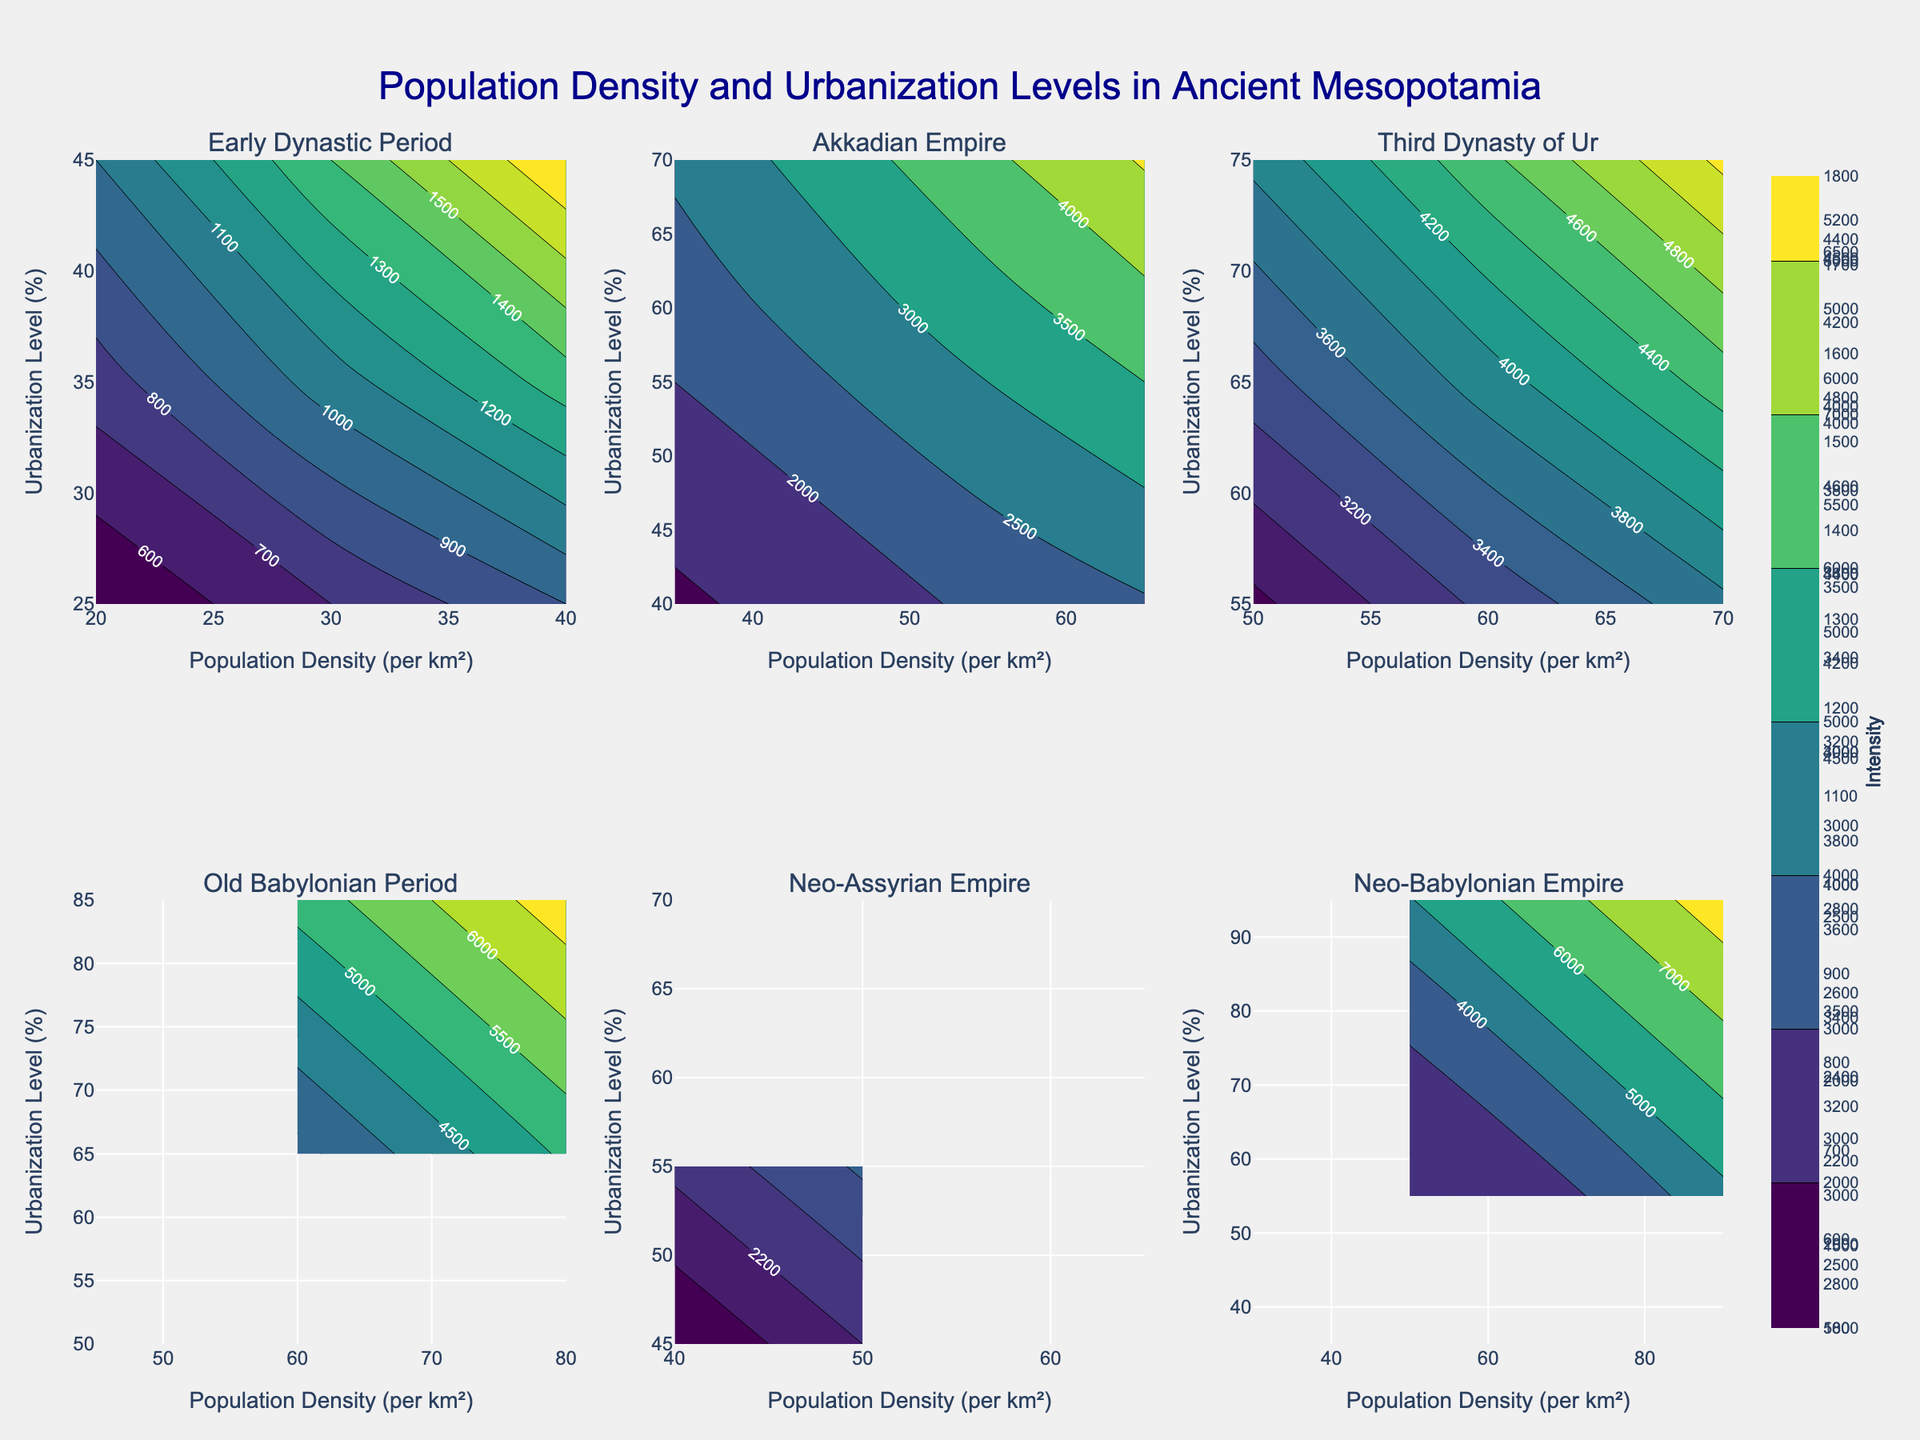What's the title of the figure? The title of the figure is displayed at the top center of the plot. It reads "Population Density and Urbanization Levels in Ancient Mesopotamia".
Answer: Population Density and Urbanization Levels in Ancient Mesopotamia How many periods are shown in the figure? The figure contains subplots for each unique period mentioned in the dataframe. By counting the subplot titles, we can see there are six periods displayed.
Answer: Six Which period has the highest urbanization level percentage in its contour plot? By examining the individual contour plots, we see that the Neo-Babylonian Empire has the highest urbanization level percentage, with levels reaching 95%.
Answer: Neo-Babylonian Empire In terms of population density, which region had the highest value in the Old Babylonian Period? From the contour plot corresponding to the Old Babylonian Period, we identify that Babylon had the highest population density, which was 80 per km².
Answer: Babylon Compare the population density levels in the Early Dynastic Period and the Neo-Assyrian Empire. Which period had a wider range of population densities? We compare the ranges of population densities for both periods. Early Dynastic Period's densities range from 20 to 40, while Neo-Assyrian Empire's densities range from 40 to 65. Thus, Neo-Assyrian Empire has a wider range.
Answer: Neo-Assyrian Empire How does the urbanization level trend from the Early Dynastic Period to the Neo-Babylonian Empire? Observing the plots from each period sequentially, we see an upward trend in urbanization levels. The levels increase from around 25%-45% in the Early Dynastic Period to as high as 95% in the Neo-Babylonian Empire.
Answer: Increases Calculate the average population density in the Third Dynasty of Ur period. In the Third Dynasty of Ur subplot, the population densities for Ur, Nippur, and Lagash are 70, 60, and 50 respectively. The average population density is calculated as (70 + 60 + 50) / 3.
Answer: 60 Which two periods show a similar range and intensity in the contour plots? By examining the contour plots, the Akkadian Empire and Neo-Assyrian Empire show similar population density ranges (35 to 70 and 40 to 65 respectively) and similar urbanization levels (35%-70% for Akkadian and 45%-70% for Neo-Assyrian).
Answer: Akkadian Empire and Neo-Assyrian Empire What is the relationship between population density and urbanization level in terms of contour plots? In most contour plots, higher population densities tend to correlate with higher urbanization levels, shown through the varying intensity colors in the places where the values are higher on both axes.
Answer: Positive correlation 